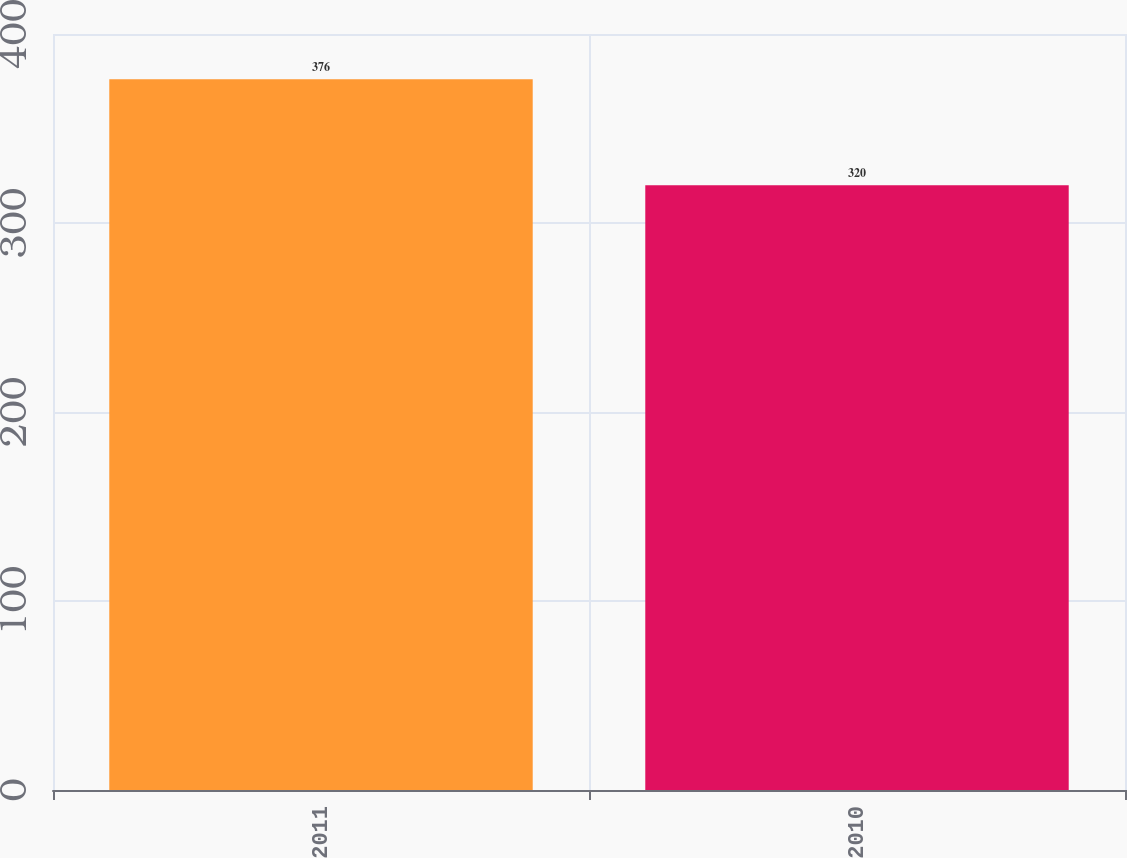Convert chart to OTSL. <chart><loc_0><loc_0><loc_500><loc_500><bar_chart><fcel>2011<fcel>2010<nl><fcel>376<fcel>320<nl></chart> 